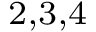<formula> <loc_0><loc_0><loc_500><loc_500>^ { 2 , 3 , 4 }</formula> 